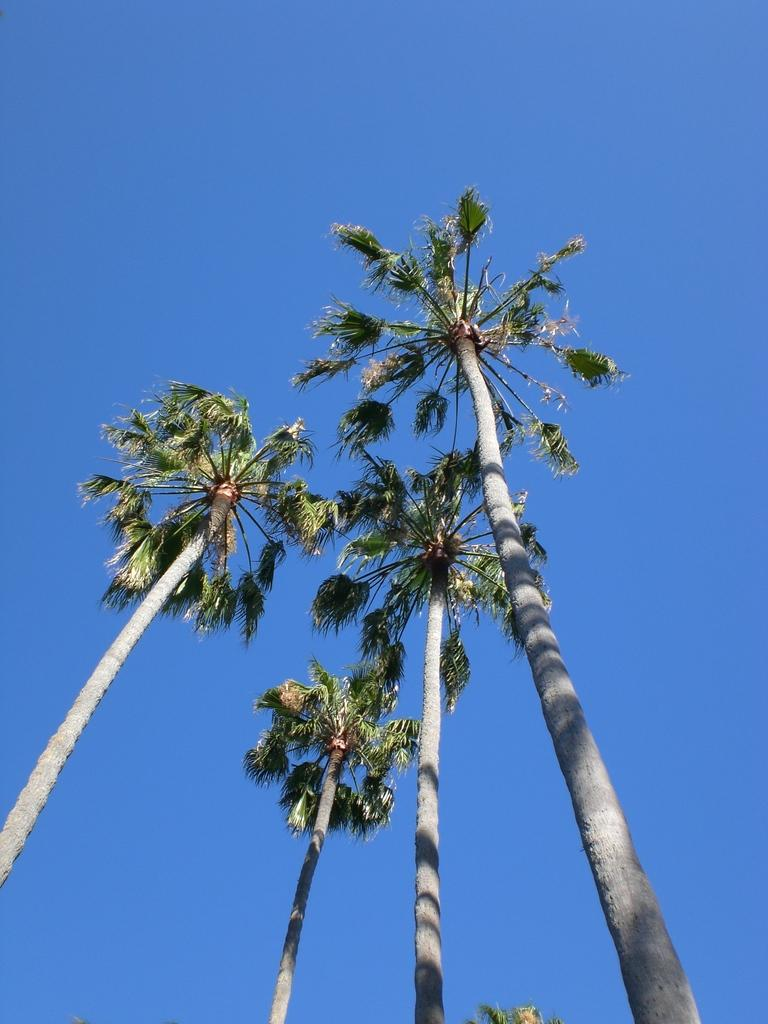What type of vegetation can be seen in the image? There are trees in the image. What part of the natural environment is visible in the image? The sky is visible in the image. What type of beast can be seen roaming in the image? There is no beast present in the image; it only features trees and the sky. How many times does the number five appear in the image? The number five is not mentioned or depicted in the image. 